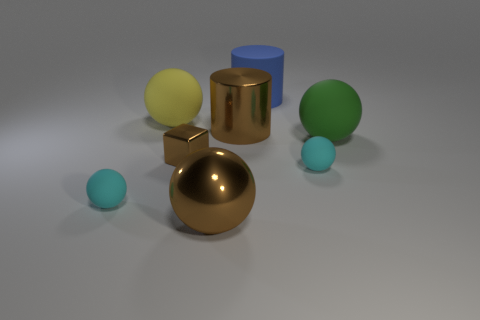Subtract all cyan spheres. How many were subtracted if there are1cyan spheres left? 1 Subtract all gray cylinders. How many cyan spheres are left? 2 Add 1 small blocks. How many objects exist? 9 Subtract all big green matte spheres. How many spheres are left? 4 Subtract all cyan spheres. How many spheres are left? 3 Subtract 2 spheres. How many spheres are left? 3 Add 4 small green things. How many small green things exist? 4 Subtract 0 gray cubes. How many objects are left? 8 Subtract all balls. How many objects are left? 3 Subtract all gray cylinders. Subtract all red cubes. How many cylinders are left? 2 